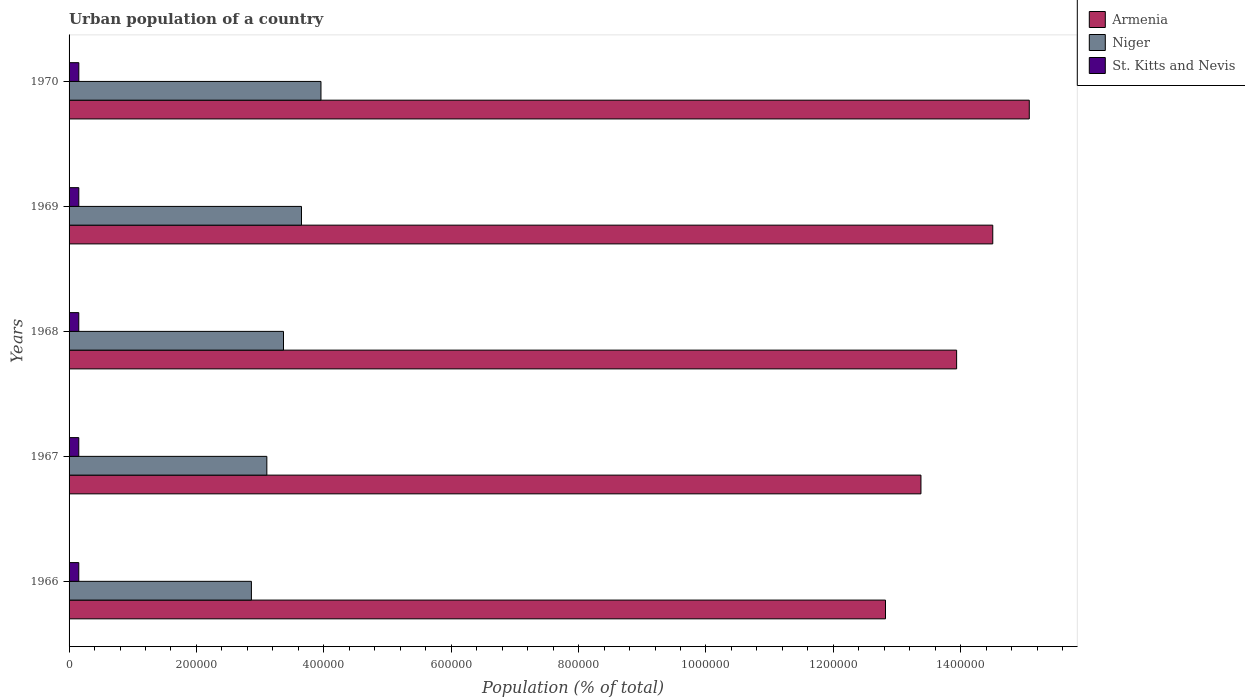What is the label of the 5th group of bars from the top?
Your answer should be compact. 1966. What is the urban population in Armenia in 1967?
Your answer should be compact. 1.34e+06. Across all years, what is the maximum urban population in St. Kitts and Nevis?
Keep it short and to the point. 1.53e+04. Across all years, what is the minimum urban population in Armenia?
Your answer should be very brief. 1.28e+06. In which year was the urban population in St. Kitts and Nevis maximum?
Offer a very short reply. 1970. In which year was the urban population in Niger minimum?
Keep it short and to the point. 1966. What is the total urban population in St. Kitts and Nevis in the graph?
Offer a very short reply. 7.64e+04. What is the difference between the urban population in St. Kitts and Nevis in 1966 and that in 1968?
Give a very brief answer. -13. What is the difference between the urban population in Niger in 1970 and the urban population in St. Kitts and Nevis in 1969?
Offer a terse response. 3.80e+05. What is the average urban population in St. Kitts and Nevis per year?
Make the answer very short. 1.53e+04. In the year 1968, what is the difference between the urban population in Niger and urban population in Armenia?
Offer a very short reply. -1.06e+06. In how many years, is the urban population in Niger greater than 80000 %?
Make the answer very short. 5. What is the ratio of the urban population in Armenia in 1967 to that in 1970?
Your answer should be very brief. 0.89. Is the urban population in Armenia in 1967 less than that in 1969?
Your answer should be very brief. Yes. What is the difference between the highest and the second highest urban population in Niger?
Keep it short and to the point. 3.06e+04. What is the difference between the highest and the lowest urban population in Niger?
Provide a short and direct response. 1.09e+05. What does the 1st bar from the top in 1967 represents?
Your response must be concise. St. Kitts and Nevis. What does the 2nd bar from the bottom in 1966 represents?
Your answer should be compact. Niger. Is it the case that in every year, the sum of the urban population in Armenia and urban population in St. Kitts and Nevis is greater than the urban population in Niger?
Make the answer very short. Yes. How many bars are there?
Your answer should be very brief. 15. How many years are there in the graph?
Provide a short and direct response. 5. What is the difference between two consecutive major ticks on the X-axis?
Provide a succinct answer. 2.00e+05. Are the values on the major ticks of X-axis written in scientific E-notation?
Give a very brief answer. No. Does the graph contain any zero values?
Make the answer very short. No. How are the legend labels stacked?
Your answer should be compact. Vertical. What is the title of the graph?
Your answer should be compact. Urban population of a country. What is the label or title of the X-axis?
Offer a terse response. Population (% of total). What is the Population (% of total) in Armenia in 1966?
Offer a very short reply. 1.28e+06. What is the Population (% of total) in Niger in 1966?
Give a very brief answer. 2.86e+05. What is the Population (% of total) of St. Kitts and Nevis in 1966?
Provide a short and direct response. 1.52e+04. What is the Population (% of total) in Armenia in 1967?
Your answer should be compact. 1.34e+06. What is the Population (% of total) of Niger in 1967?
Make the answer very short. 3.11e+05. What is the Population (% of total) of St. Kitts and Nevis in 1967?
Your answer should be very brief. 1.53e+04. What is the Population (% of total) in Armenia in 1968?
Keep it short and to the point. 1.39e+06. What is the Population (% of total) in Niger in 1968?
Make the answer very short. 3.37e+05. What is the Population (% of total) of St. Kitts and Nevis in 1968?
Give a very brief answer. 1.53e+04. What is the Population (% of total) in Armenia in 1969?
Make the answer very short. 1.45e+06. What is the Population (% of total) of Niger in 1969?
Provide a short and direct response. 3.65e+05. What is the Population (% of total) in St. Kitts and Nevis in 1969?
Your response must be concise. 1.53e+04. What is the Population (% of total) of Armenia in 1970?
Provide a succinct answer. 1.51e+06. What is the Population (% of total) of Niger in 1970?
Provide a succinct answer. 3.95e+05. What is the Population (% of total) in St. Kitts and Nevis in 1970?
Provide a short and direct response. 1.53e+04. Across all years, what is the maximum Population (% of total) of Armenia?
Your response must be concise. 1.51e+06. Across all years, what is the maximum Population (% of total) in Niger?
Your response must be concise. 3.95e+05. Across all years, what is the maximum Population (% of total) of St. Kitts and Nevis?
Ensure brevity in your answer.  1.53e+04. Across all years, what is the minimum Population (% of total) of Armenia?
Offer a very short reply. 1.28e+06. Across all years, what is the minimum Population (% of total) of Niger?
Your answer should be very brief. 2.86e+05. Across all years, what is the minimum Population (% of total) of St. Kitts and Nevis?
Ensure brevity in your answer.  1.52e+04. What is the total Population (% of total) in Armenia in the graph?
Keep it short and to the point. 6.97e+06. What is the total Population (% of total) of Niger in the graph?
Your answer should be compact. 1.69e+06. What is the total Population (% of total) of St. Kitts and Nevis in the graph?
Ensure brevity in your answer.  7.64e+04. What is the difference between the Population (% of total) of Armenia in 1966 and that in 1967?
Provide a succinct answer. -5.57e+04. What is the difference between the Population (% of total) of Niger in 1966 and that in 1967?
Provide a short and direct response. -2.42e+04. What is the difference between the Population (% of total) in St. Kitts and Nevis in 1966 and that in 1967?
Offer a very short reply. -13. What is the difference between the Population (% of total) in Armenia in 1966 and that in 1968?
Keep it short and to the point. -1.12e+05. What is the difference between the Population (% of total) in Niger in 1966 and that in 1968?
Keep it short and to the point. -5.04e+04. What is the difference between the Population (% of total) of Armenia in 1966 and that in 1969?
Your response must be concise. -1.68e+05. What is the difference between the Population (% of total) of Niger in 1966 and that in 1969?
Keep it short and to the point. -7.86e+04. What is the difference between the Population (% of total) in St. Kitts and Nevis in 1966 and that in 1969?
Offer a terse response. -42. What is the difference between the Population (% of total) of Armenia in 1966 and that in 1970?
Ensure brevity in your answer.  -2.26e+05. What is the difference between the Population (% of total) in Niger in 1966 and that in 1970?
Give a very brief answer. -1.09e+05. What is the difference between the Population (% of total) in St. Kitts and Nevis in 1966 and that in 1970?
Your response must be concise. -81. What is the difference between the Population (% of total) of Armenia in 1967 and that in 1968?
Your response must be concise. -5.60e+04. What is the difference between the Population (% of total) of Niger in 1967 and that in 1968?
Provide a short and direct response. -2.61e+04. What is the difference between the Population (% of total) of St. Kitts and Nevis in 1967 and that in 1968?
Your response must be concise. 0. What is the difference between the Population (% of total) in Armenia in 1967 and that in 1969?
Ensure brevity in your answer.  -1.13e+05. What is the difference between the Population (% of total) in Niger in 1967 and that in 1969?
Make the answer very short. -5.44e+04. What is the difference between the Population (% of total) of Armenia in 1967 and that in 1970?
Provide a short and direct response. -1.70e+05. What is the difference between the Population (% of total) in Niger in 1967 and that in 1970?
Provide a succinct answer. -8.50e+04. What is the difference between the Population (% of total) in St. Kitts and Nevis in 1967 and that in 1970?
Provide a succinct answer. -68. What is the difference between the Population (% of total) of Armenia in 1968 and that in 1969?
Your response must be concise. -5.67e+04. What is the difference between the Population (% of total) in Niger in 1968 and that in 1969?
Provide a succinct answer. -2.82e+04. What is the difference between the Population (% of total) in Armenia in 1968 and that in 1970?
Keep it short and to the point. -1.14e+05. What is the difference between the Population (% of total) of Niger in 1968 and that in 1970?
Provide a short and direct response. -5.88e+04. What is the difference between the Population (% of total) in St. Kitts and Nevis in 1968 and that in 1970?
Offer a terse response. -68. What is the difference between the Population (% of total) in Armenia in 1969 and that in 1970?
Offer a terse response. -5.73e+04. What is the difference between the Population (% of total) in Niger in 1969 and that in 1970?
Give a very brief answer. -3.06e+04. What is the difference between the Population (% of total) in St. Kitts and Nevis in 1969 and that in 1970?
Ensure brevity in your answer.  -39. What is the difference between the Population (% of total) of Armenia in 1966 and the Population (% of total) of Niger in 1967?
Ensure brevity in your answer.  9.71e+05. What is the difference between the Population (% of total) of Armenia in 1966 and the Population (% of total) of St. Kitts and Nevis in 1967?
Offer a very short reply. 1.27e+06. What is the difference between the Population (% of total) of Niger in 1966 and the Population (% of total) of St. Kitts and Nevis in 1967?
Provide a succinct answer. 2.71e+05. What is the difference between the Population (% of total) in Armenia in 1966 and the Population (% of total) in Niger in 1968?
Your answer should be compact. 9.45e+05. What is the difference between the Population (% of total) in Armenia in 1966 and the Population (% of total) in St. Kitts and Nevis in 1968?
Offer a terse response. 1.27e+06. What is the difference between the Population (% of total) of Niger in 1966 and the Population (% of total) of St. Kitts and Nevis in 1968?
Offer a terse response. 2.71e+05. What is the difference between the Population (% of total) in Armenia in 1966 and the Population (% of total) in Niger in 1969?
Your response must be concise. 9.17e+05. What is the difference between the Population (% of total) in Armenia in 1966 and the Population (% of total) in St. Kitts and Nevis in 1969?
Ensure brevity in your answer.  1.27e+06. What is the difference between the Population (% of total) of Niger in 1966 and the Population (% of total) of St. Kitts and Nevis in 1969?
Ensure brevity in your answer.  2.71e+05. What is the difference between the Population (% of total) in Armenia in 1966 and the Population (% of total) in Niger in 1970?
Provide a succinct answer. 8.86e+05. What is the difference between the Population (% of total) in Armenia in 1966 and the Population (% of total) in St. Kitts and Nevis in 1970?
Your response must be concise. 1.27e+06. What is the difference between the Population (% of total) of Niger in 1966 and the Population (% of total) of St. Kitts and Nevis in 1970?
Provide a succinct answer. 2.71e+05. What is the difference between the Population (% of total) in Armenia in 1967 and the Population (% of total) in Niger in 1968?
Your answer should be very brief. 1.00e+06. What is the difference between the Population (% of total) of Armenia in 1967 and the Population (% of total) of St. Kitts and Nevis in 1968?
Offer a terse response. 1.32e+06. What is the difference between the Population (% of total) in Niger in 1967 and the Population (% of total) in St. Kitts and Nevis in 1968?
Offer a very short reply. 2.95e+05. What is the difference between the Population (% of total) in Armenia in 1967 and the Population (% of total) in Niger in 1969?
Offer a terse response. 9.73e+05. What is the difference between the Population (% of total) of Armenia in 1967 and the Population (% of total) of St. Kitts and Nevis in 1969?
Your response must be concise. 1.32e+06. What is the difference between the Population (% of total) in Niger in 1967 and the Population (% of total) in St. Kitts and Nevis in 1969?
Ensure brevity in your answer.  2.95e+05. What is the difference between the Population (% of total) in Armenia in 1967 and the Population (% of total) in Niger in 1970?
Your response must be concise. 9.42e+05. What is the difference between the Population (% of total) in Armenia in 1967 and the Population (% of total) in St. Kitts and Nevis in 1970?
Provide a succinct answer. 1.32e+06. What is the difference between the Population (% of total) in Niger in 1967 and the Population (% of total) in St. Kitts and Nevis in 1970?
Give a very brief answer. 2.95e+05. What is the difference between the Population (% of total) of Armenia in 1968 and the Population (% of total) of Niger in 1969?
Make the answer very short. 1.03e+06. What is the difference between the Population (% of total) in Armenia in 1968 and the Population (% of total) in St. Kitts and Nevis in 1969?
Offer a terse response. 1.38e+06. What is the difference between the Population (% of total) in Niger in 1968 and the Population (% of total) in St. Kitts and Nevis in 1969?
Make the answer very short. 3.21e+05. What is the difference between the Population (% of total) in Armenia in 1968 and the Population (% of total) in Niger in 1970?
Offer a terse response. 9.98e+05. What is the difference between the Population (% of total) in Armenia in 1968 and the Population (% of total) in St. Kitts and Nevis in 1970?
Provide a short and direct response. 1.38e+06. What is the difference between the Population (% of total) in Niger in 1968 and the Population (% of total) in St. Kitts and Nevis in 1970?
Offer a terse response. 3.21e+05. What is the difference between the Population (% of total) in Armenia in 1969 and the Population (% of total) in Niger in 1970?
Your answer should be compact. 1.05e+06. What is the difference between the Population (% of total) in Armenia in 1969 and the Population (% of total) in St. Kitts and Nevis in 1970?
Your response must be concise. 1.43e+06. What is the difference between the Population (% of total) of Niger in 1969 and the Population (% of total) of St. Kitts and Nevis in 1970?
Offer a terse response. 3.50e+05. What is the average Population (% of total) in Armenia per year?
Keep it short and to the point. 1.39e+06. What is the average Population (% of total) in Niger per year?
Give a very brief answer. 3.39e+05. What is the average Population (% of total) of St. Kitts and Nevis per year?
Offer a terse response. 1.53e+04. In the year 1966, what is the difference between the Population (% of total) of Armenia and Population (% of total) of Niger?
Your answer should be very brief. 9.96e+05. In the year 1966, what is the difference between the Population (% of total) in Armenia and Population (% of total) in St. Kitts and Nevis?
Provide a short and direct response. 1.27e+06. In the year 1966, what is the difference between the Population (% of total) in Niger and Population (% of total) in St. Kitts and Nevis?
Give a very brief answer. 2.71e+05. In the year 1967, what is the difference between the Population (% of total) of Armenia and Population (% of total) of Niger?
Keep it short and to the point. 1.03e+06. In the year 1967, what is the difference between the Population (% of total) of Armenia and Population (% of total) of St. Kitts and Nevis?
Keep it short and to the point. 1.32e+06. In the year 1967, what is the difference between the Population (% of total) of Niger and Population (% of total) of St. Kitts and Nevis?
Give a very brief answer. 2.95e+05. In the year 1968, what is the difference between the Population (% of total) in Armenia and Population (% of total) in Niger?
Your response must be concise. 1.06e+06. In the year 1968, what is the difference between the Population (% of total) in Armenia and Population (% of total) in St. Kitts and Nevis?
Offer a very short reply. 1.38e+06. In the year 1968, what is the difference between the Population (% of total) in Niger and Population (% of total) in St. Kitts and Nevis?
Your answer should be compact. 3.21e+05. In the year 1969, what is the difference between the Population (% of total) in Armenia and Population (% of total) in Niger?
Make the answer very short. 1.09e+06. In the year 1969, what is the difference between the Population (% of total) of Armenia and Population (% of total) of St. Kitts and Nevis?
Your answer should be very brief. 1.44e+06. In the year 1969, what is the difference between the Population (% of total) of Niger and Population (% of total) of St. Kitts and Nevis?
Your answer should be compact. 3.50e+05. In the year 1970, what is the difference between the Population (% of total) of Armenia and Population (% of total) of Niger?
Your answer should be compact. 1.11e+06. In the year 1970, what is the difference between the Population (% of total) of Armenia and Population (% of total) of St. Kitts and Nevis?
Your response must be concise. 1.49e+06. In the year 1970, what is the difference between the Population (% of total) of Niger and Population (% of total) of St. Kitts and Nevis?
Ensure brevity in your answer.  3.80e+05. What is the ratio of the Population (% of total) of Armenia in 1966 to that in 1967?
Your answer should be compact. 0.96. What is the ratio of the Population (% of total) in Niger in 1966 to that in 1967?
Provide a succinct answer. 0.92. What is the ratio of the Population (% of total) of St. Kitts and Nevis in 1966 to that in 1967?
Make the answer very short. 1. What is the ratio of the Population (% of total) in Armenia in 1966 to that in 1968?
Offer a very short reply. 0.92. What is the ratio of the Population (% of total) of Niger in 1966 to that in 1968?
Offer a terse response. 0.85. What is the ratio of the Population (% of total) of St. Kitts and Nevis in 1966 to that in 1968?
Provide a short and direct response. 1. What is the ratio of the Population (% of total) in Armenia in 1966 to that in 1969?
Provide a short and direct response. 0.88. What is the ratio of the Population (% of total) in Niger in 1966 to that in 1969?
Your answer should be very brief. 0.78. What is the ratio of the Population (% of total) of St. Kitts and Nevis in 1966 to that in 1969?
Ensure brevity in your answer.  1. What is the ratio of the Population (% of total) of Armenia in 1966 to that in 1970?
Ensure brevity in your answer.  0.85. What is the ratio of the Population (% of total) in Niger in 1966 to that in 1970?
Keep it short and to the point. 0.72. What is the ratio of the Population (% of total) of Armenia in 1967 to that in 1968?
Your answer should be compact. 0.96. What is the ratio of the Population (% of total) of Niger in 1967 to that in 1968?
Provide a succinct answer. 0.92. What is the ratio of the Population (% of total) in St. Kitts and Nevis in 1967 to that in 1968?
Give a very brief answer. 1. What is the ratio of the Population (% of total) of Armenia in 1967 to that in 1969?
Your response must be concise. 0.92. What is the ratio of the Population (% of total) in Niger in 1967 to that in 1969?
Offer a terse response. 0.85. What is the ratio of the Population (% of total) in Armenia in 1967 to that in 1970?
Provide a short and direct response. 0.89. What is the ratio of the Population (% of total) of Niger in 1967 to that in 1970?
Your answer should be compact. 0.79. What is the ratio of the Population (% of total) in Armenia in 1968 to that in 1969?
Provide a succinct answer. 0.96. What is the ratio of the Population (% of total) of Niger in 1968 to that in 1969?
Provide a succinct answer. 0.92. What is the ratio of the Population (% of total) of Armenia in 1968 to that in 1970?
Your response must be concise. 0.92. What is the ratio of the Population (% of total) of Niger in 1968 to that in 1970?
Give a very brief answer. 0.85. What is the ratio of the Population (% of total) of Armenia in 1969 to that in 1970?
Offer a terse response. 0.96. What is the ratio of the Population (% of total) of Niger in 1969 to that in 1970?
Your response must be concise. 0.92. What is the ratio of the Population (% of total) of St. Kitts and Nevis in 1969 to that in 1970?
Ensure brevity in your answer.  1. What is the difference between the highest and the second highest Population (% of total) of Armenia?
Your response must be concise. 5.73e+04. What is the difference between the highest and the second highest Population (% of total) of Niger?
Keep it short and to the point. 3.06e+04. What is the difference between the highest and the second highest Population (% of total) in St. Kitts and Nevis?
Keep it short and to the point. 39. What is the difference between the highest and the lowest Population (% of total) in Armenia?
Offer a very short reply. 2.26e+05. What is the difference between the highest and the lowest Population (% of total) of Niger?
Offer a terse response. 1.09e+05. 